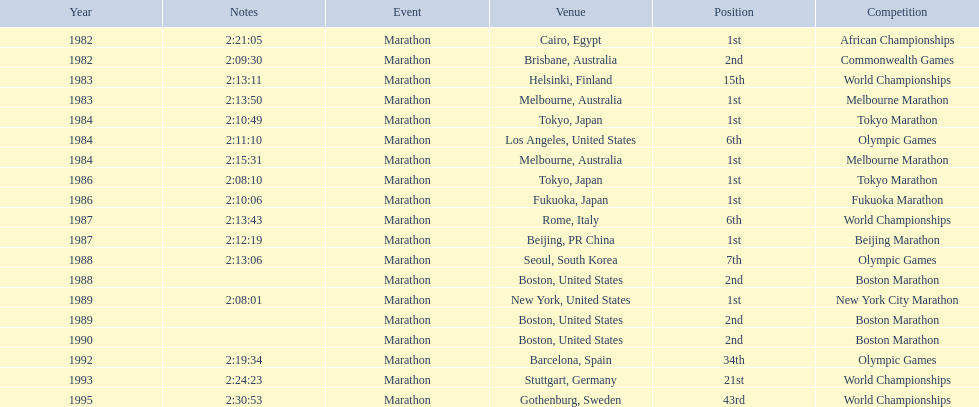What are the competitions? African Championships, Cairo, Egypt, Commonwealth Games, Brisbane, Australia, World Championships, Helsinki, Finland, Melbourne Marathon, Melbourne, Australia, Tokyo Marathon, Tokyo, Japan, Olympic Games, Los Angeles, United States, Melbourne Marathon, Melbourne, Australia, Tokyo Marathon, Tokyo, Japan, Fukuoka Marathon, Fukuoka, Japan, World Championships, Rome, Italy, Beijing Marathon, Beijing, PR China, Olympic Games, Seoul, South Korea, Boston Marathon, Boston, United States, New York City Marathon, New York, United States, Boston Marathon, Boston, United States, Boston Marathon, Boston, United States, Olympic Games, Barcelona, Spain, World Championships, Stuttgart, Germany, World Championships, Gothenburg, Sweden. Which ones occured in china? Beijing Marathon, Beijing, PR China. Which one is it? Beijing Marathon. 